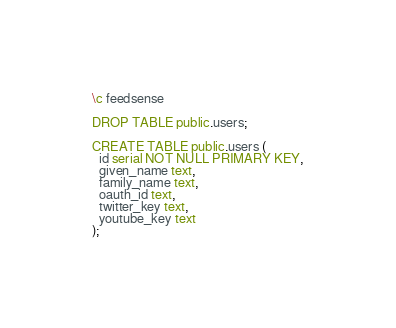<code> <loc_0><loc_0><loc_500><loc_500><_SQL_>\c feedsense

DROP TABLE public.users;

CREATE TABLE public.users (
  id serial NOT NULL PRIMARY KEY,
  given_name text,
  family_name text,
  oauth_id text,
  twitter_key text,
  youtube_key text
);
</code> 